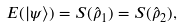Convert formula to latex. <formula><loc_0><loc_0><loc_500><loc_500>E ( | \psi \rangle ) = S ( \hat { \rho } _ { 1 } ) = S ( \hat { \rho } _ { 2 } ) ,</formula> 